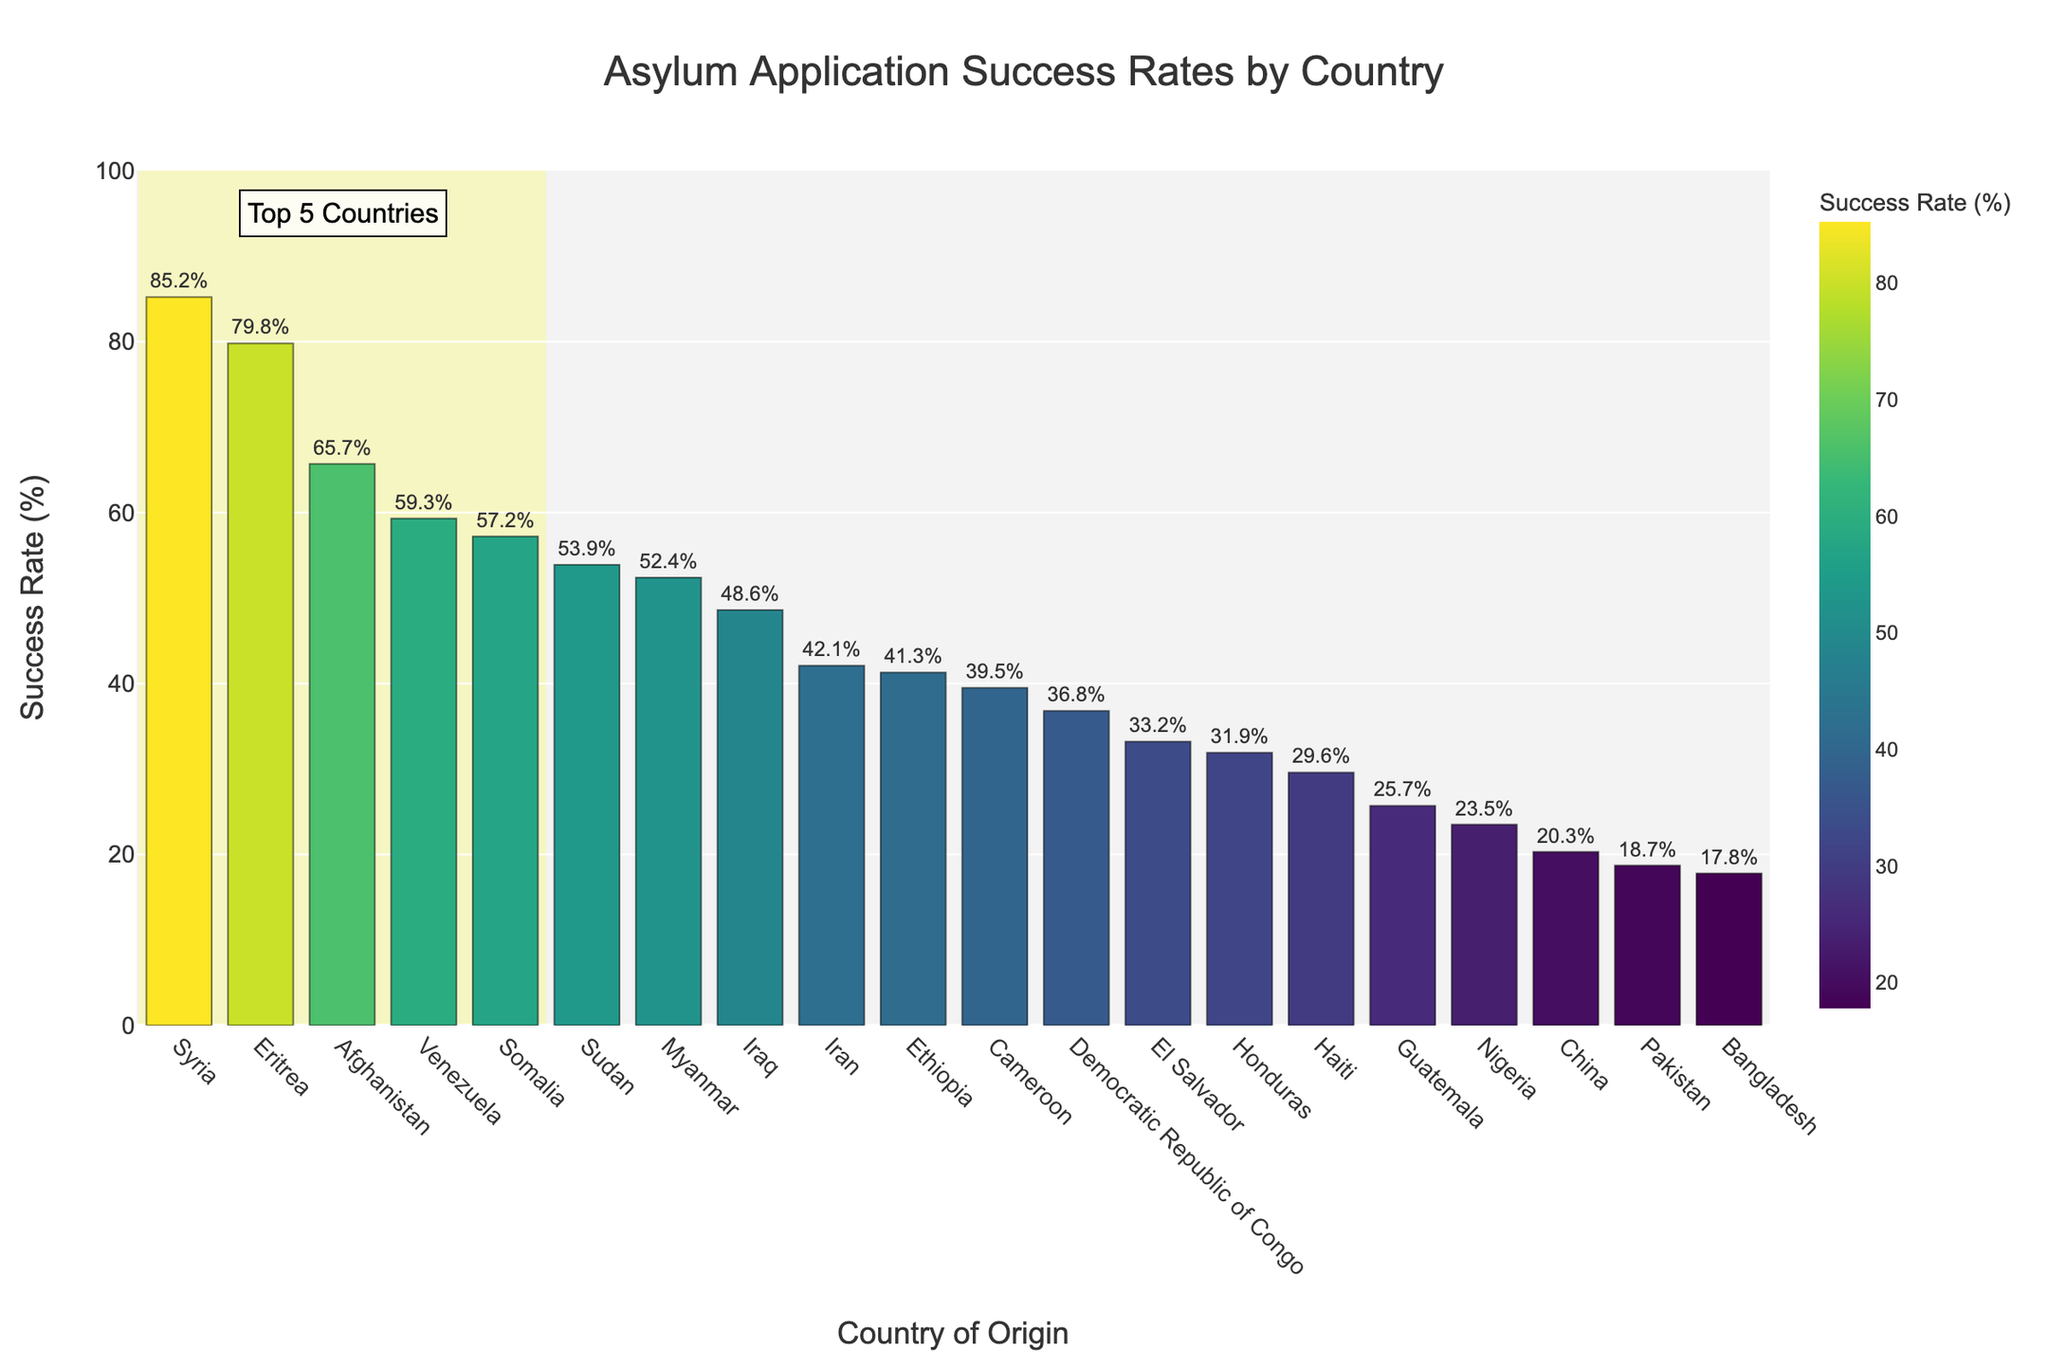Which country has the highest asylum application success rate? By examining the bar chart, we see that Syria has the highest bar, indicating the highest asylum application success rate.
Answer: Syria What is the asylum application success rate for Nigeria? Looking at the bar labeled "Nigeria" in the chart, we observe that the associated value is 23.5%.
Answer: 23.5% Identify the top 5 countries with the highest asylum application success rates. The figure highlights the top 5 countries with a shaded rectangle. The countries within this area are Syria, Eritrea, Afghanistan, Venezuela, and Somalia.
Answer: Syria, Eritrea, Afghanistan, Venezuela, Somalia What is the average success rate of asylum applications for the bottom 3 countries? The bottom 3 countries are Bangladesh (17.8%), Pakistan (18.7%), and Nigeria (23.5%). So, the average is (17.8 + 18.7 + 23.5) / 3 = 20.
Answer: 20% Which group has a lower asylum application success rate, Iran or Iraq? Comparing the heights of the bars for Iran and Iraq, we see that Iran's success rate (42.1%) is lower than Iraq's success rate (48.6%).
Answer: Iran Is Iran's asylum application success rate above or below the median success rate of all the countries? To find the median, we need to arrange the rates in ascending order and find the middle value. The middle value is roughly between 41.3% and 42.1%. Since Iran's rate is 42.1%, it is slightly above the median.
Answer: Above Which country among Venezuela, Eritrea, and Somalia has the highest asylum application success rate? Observing the bars for Venezuela (59.3%), Eritrea (79.8%), and Somalia (57.2%), Eritrea has the highest success rate.
Answer: Eritrea What's the difference in asylum application success rates between Ethiopia and Democratic Republic of Congo? The success rate for Ethiopia is 41.3% and for the Democratic Republic of Congo is 36.8%. The difference is 41.3 - 36.8 = 4.5%.
Answer: 4.5% How many countries have an asylum application success rate higher than 50%? Counting the bars with values above 50%, we find that 8 countries (Syria, Eritrea, Afghanistan, Venezuela, Myanmar, Somalia, Sudan, Iraq) have a success rate higher than 50%.
Answer: 8 